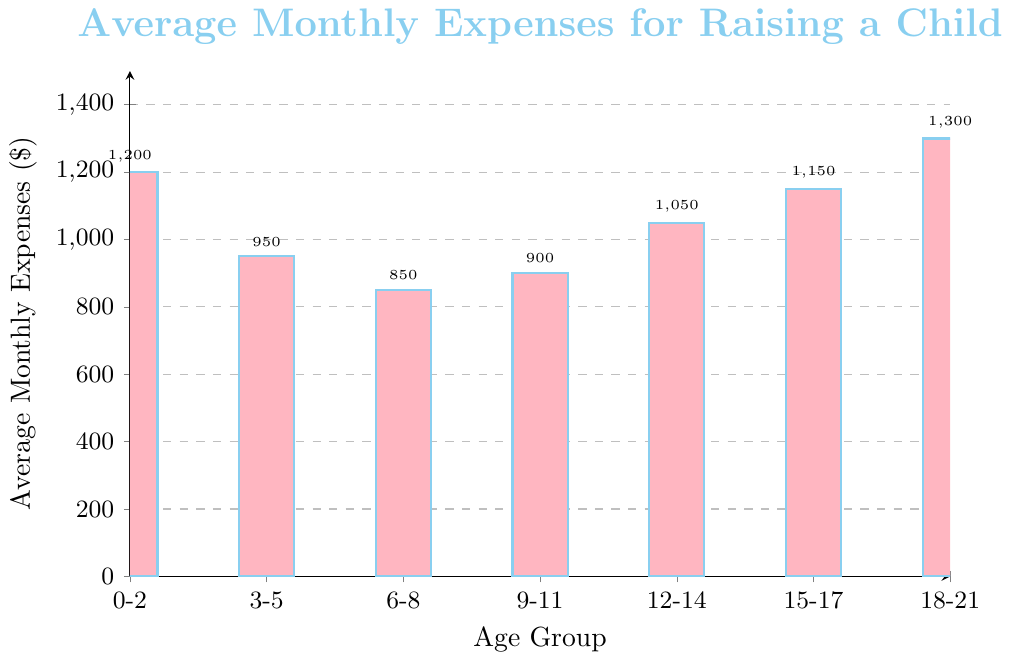What is the age group with the highest average monthly expenses? Look for the tallest bar in the chart, which represents the highest value.
Answer: 18-21 years What is the difference in average monthly expenses between the 0-2 years age group and the 3-5 years age group? Subtract the height of the bar for the 3-5 years (950) from the height of the bar for the 0-2 years (1200).
Answer: 250 Which age group has the lowest average monthly expenses? Identify the shortest bar in the chart, corresponding to the lowest value.
Answer: 6-8 years How much more does it cost on average per month to raise a child in the 18-21 years group compared to the 6-8 years group? Subtract the height of the bar for the 6-8 years (850) from the height of the bar for the 18-21 years (1300).
Answer: 450 What is the average of the average monthly expenses for all the age groups? Sum the values of all the bars (1200 + 950 + 850 + 900 + 1050 + 1150 + 1300) and divide by the number of age groups (7).
Answer: 1042.86 Is the average monthly expense for the 9-11 years age group greater than for the 6-8 years age group? Compare the heights of the bars for the 9-11 years (900) and 6-8 years (850) groups.
Answer: Yes Which age group has average monthly expenses that are very close to $1000? Identify the bar whose height is closest to 1000. The 12-14 years group has expenses of 1050, which is closest.
Answer: 12-14 years Are the expenses for the age group 15-17 years higher than those for the age group 12-14 years? Compare the heights of the bars for the 15-17 years (1150) and 12-14 years (1050) groups.
Answer: Yes What is the range of average monthly expenses across all the age groups? Subtract the height of the shortest bar (850) from the height of the tallest bar (1300).
Answer: 450 How do expenses change from the 0-2 years age group to the 6-8 years age group? Note the heights of bars from the 0-2 years (1200), 3-5 years (950), and 6-8 years (850) groups and observe the decreasing trend.
Answer: Decrease 